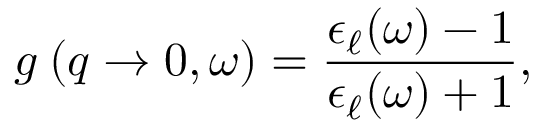<formula> <loc_0><loc_0><loc_500><loc_500>g _ { \ell } ( q \to 0 , \omega ) = \frac { \epsilon _ { \ell } ( \omega ) - 1 } { \epsilon _ { \ell } ( \omega ) + 1 } ,</formula> 